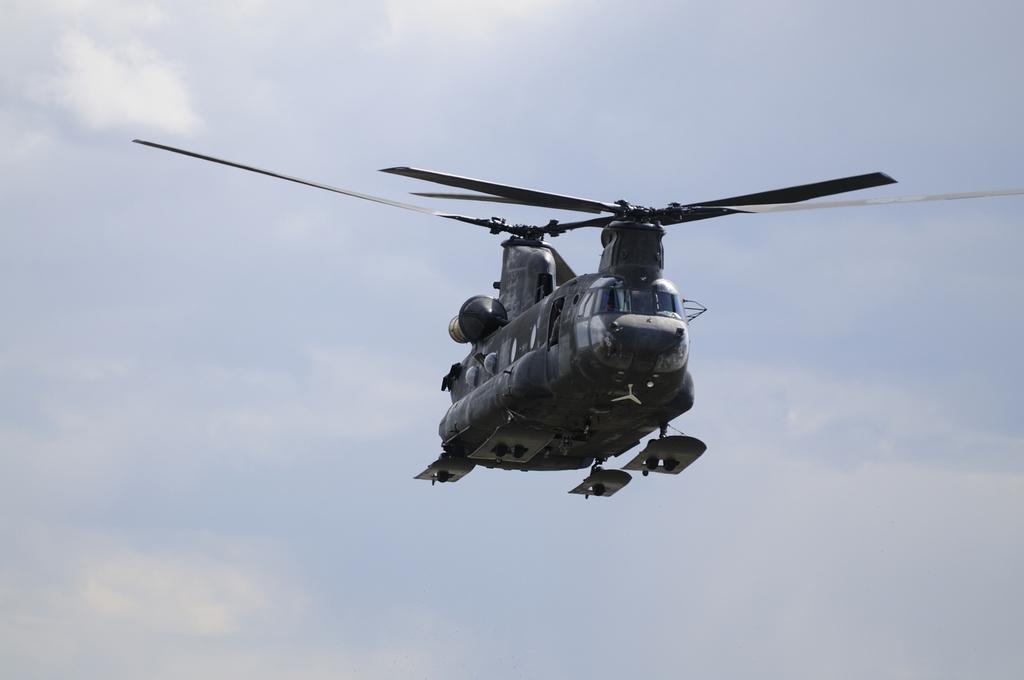Can you describe this image briefly? In this picture we can observe a military helicopter flying in the air. In the background we can observe a sky with some clouds. 